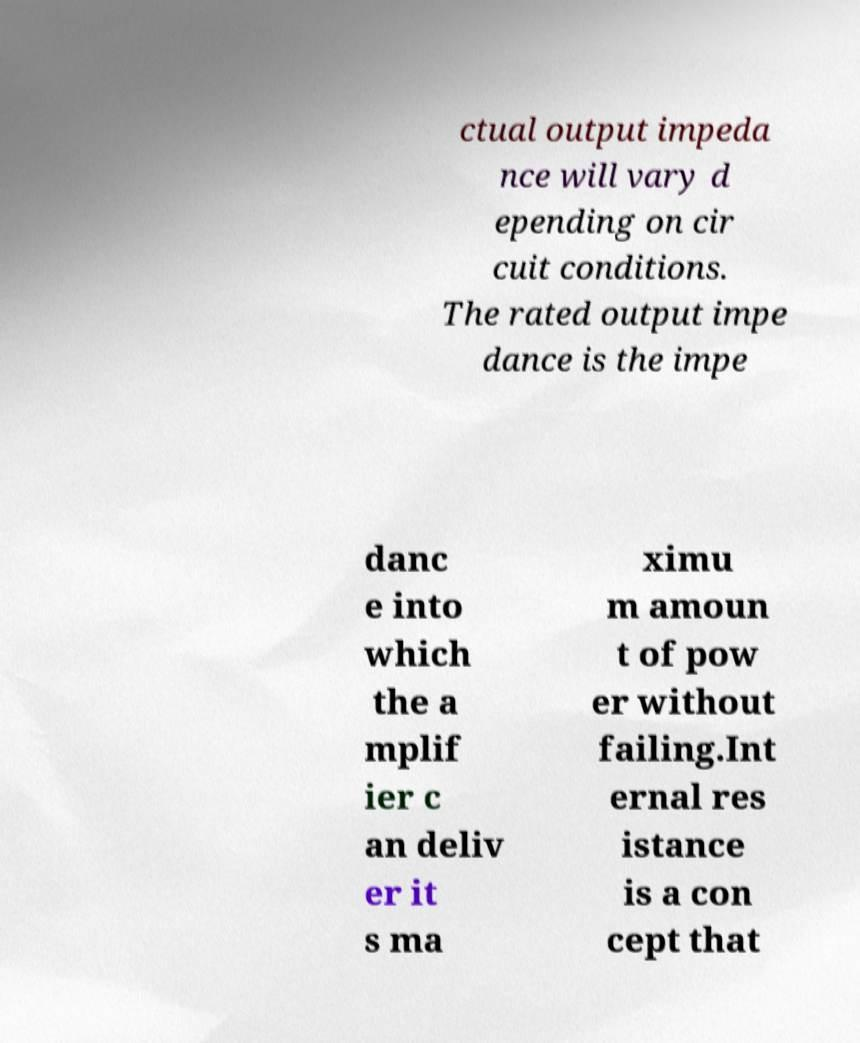What messages or text are displayed in this image? I need them in a readable, typed format. ctual output impeda nce will vary d epending on cir cuit conditions. The rated output impe dance is the impe danc e into which the a mplif ier c an deliv er it s ma ximu m amoun t of pow er without failing.Int ernal res istance is a con cept that 